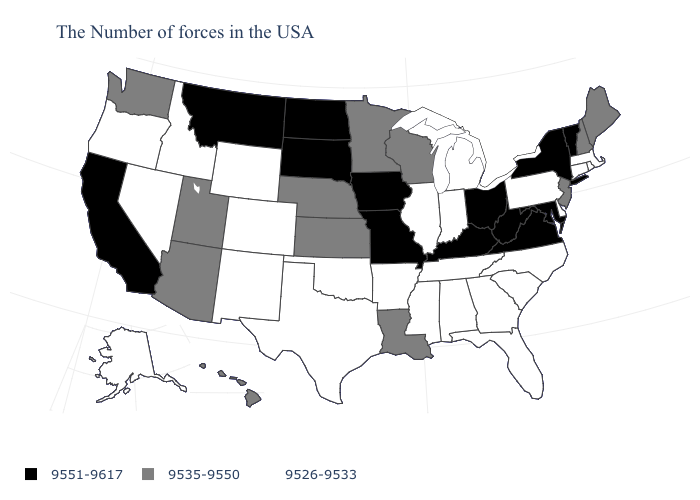What is the value of Oklahoma?
Write a very short answer. 9526-9533. Is the legend a continuous bar?
Quick response, please. No. What is the value of Indiana?
Write a very short answer. 9526-9533. Among the states that border Delaware , which have the lowest value?
Keep it brief. Pennsylvania. Name the states that have a value in the range 9526-9533?
Concise answer only. Massachusetts, Rhode Island, Connecticut, Delaware, Pennsylvania, North Carolina, South Carolina, Florida, Georgia, Michigan, Indiana, Alabama, Tennessee, Illinois, Mississippi, Arkansas, Oklahoma, Texas, Wyoming, Colorado, New Mexico, Idaho, Nevada, Oregon, Alaska. What is the highest value in the Northeast ?
Quick response, please. 9551-9617. Does Arizona have the highest value in the USA?
Keep it brief. No. What is the value of Washington?
Keep it brief. 9535-9550. Name the states that have a value in the range 9526-9533?
Write a very short answer. Massachusetts, Rhode Island, Connecticut, Delaware, Pennsylvania, North Carolina, South Carolina, Florida, Georgia, Michigan, Indiana, Alabama, Tennessee, Illinois, Mississippi, Arkansas, Oklahoma, Texas, Wyoming, Colorado, New Mexico, Idaho, Nevada, Oregon, Alaska. Which states have the lowest value in the West?
Short answer required. Wyoming, Colorado, New Mexico, Idaho, Nevada, Oregon, Alaska. How many symbols are there in the legend?
Be succinct. 3. Is the legend a continuous bar?
Keep it brief. No. Name the states that have a value in the range 9551-9617?
Be succinct. Vermont, New York, Maryland, Virginia, West Virginia, Ohio, Kentucky, Missouri, Iowa, South Dakota, North Dakota, Montana, California. What is the value of Illinois?
Give a very brief answer. 9526-9533. What is the value of North Dakota?
Quick response, please. 9551-9617. 